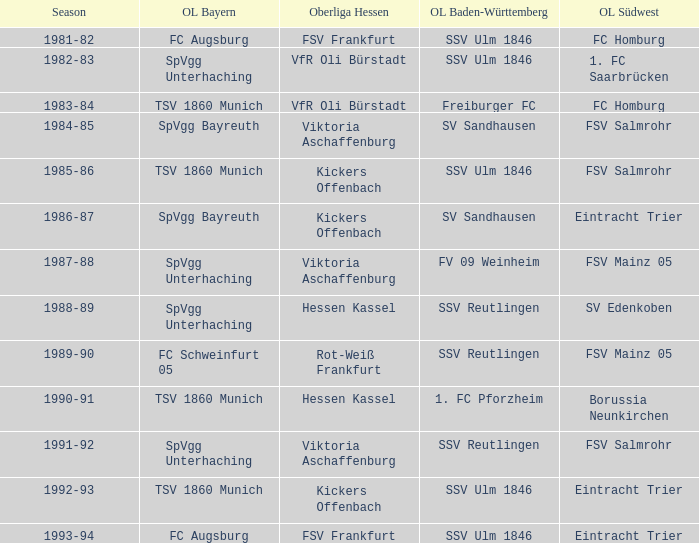Which Oberliga Baden-Württemberg has an Oberliga Hessen of fsv frankfurt in 1993-94? SSV Ulm 1846. 